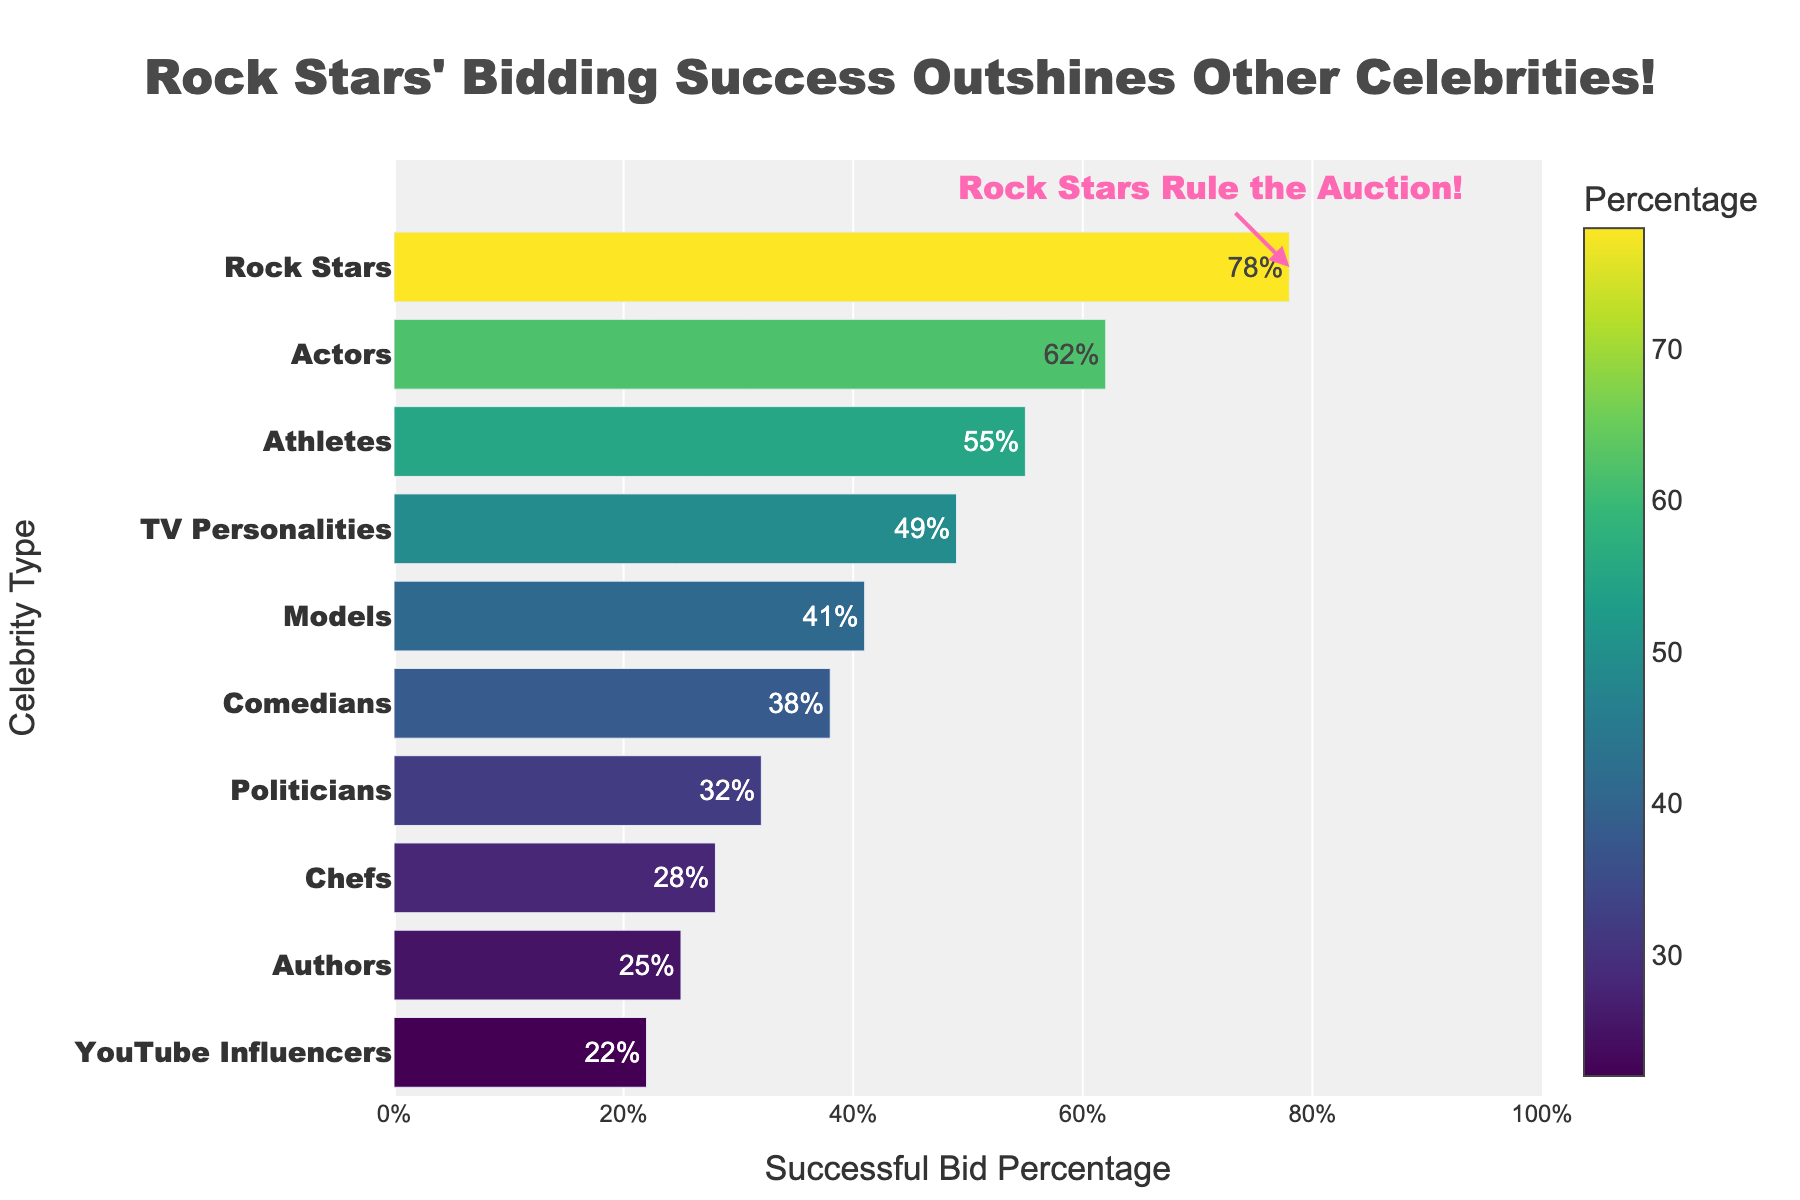What's the successful bid percentage for Rock Stars? The successful bid percentage for Rock Stars is clearly labeled on the figure. It is 78% as highlighted by the bar and text.
Answer: 78% Which celebrity type has the lowest successful bid percentage? Locate the bar with the lowest value on the y-axis, which is YouTube Influencers, and its corresponding percentage is 22%.
Answer: YouTube Influencers How much higher is the successful bid percentage for Rock Stars compared to TV Personalities? Subtract the percentage of TV Personalities (49%) from Rock Stars (78%). 78% - 49% = 29%.
Answer: 29% What's the average successful bid percentage for Actors, Athletes, and Models? Add their percentages: 62% (Actors) + 55% (Athletes) + 41% (Models) = 158%. Divide by the number of types (3), so 158% / 3 = 52.67%.
Answer: 52.67% What is the range of successful bid percentages among all celebrity types? Subtract the lowest percentage (YouTube Influencers, 22%) from the highest percentage (Rock Stars, 78%). 78% - 22% = 56%.
Answer: 56% Which two celebrity types have the greatest difference in successful bid percentage? Identify the two bars that are the furthest apart in value. Rock Stars (78%) and YouTube Influencers (22%) have the greatest difference. Subtract to confirm: 78% - 22% = 56%.
Answer: Rock Stars and YouTube Influencers Does the color intensity in the bars correlate with the successful bid percentage? Higher successful bid percentages are represented by darker shades on the color scale, which is indicated by looking at the bar colors from left (darker) to right (lighter).
Answer: Yes What is the total percentage if we sum up the successful bid percentages of Athletes, Chefs, and Comedians? Add their percentages: 55% (Athletes) + 28% (Chefs) + 38% (Comedians) = 121%.
Answer: 121% Between Comedians and Authors, which celebrity types have a higher successful bid percentage, and by how much? Compare the percentages: Comedians (38%) and Authors (25%), then subtract: 38% - 25% = 13%.
Answer: Comedians by 13% 